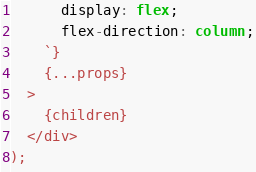<code> <loc_0><loc_0><loc_500><loc_500><_TypeScript_>      display: flex;
      flex-direction: column;
    `}
    {...props}
  >
    {children}
  </div>
);
</code> 